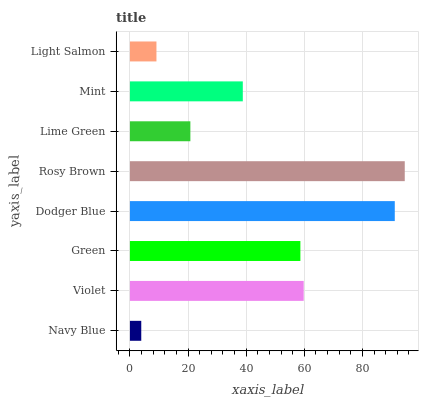Is Navy Blue the minimum?
Answer yes or no. Yes. Is Rosy Brown the maximum?
Answer yes or no. Yes. Is Violet the minimum?
Answer yes or no. No. Is Violet the maximum?
Answer yes or no. No. Is Violet greater than Navy Blue?
Answer yes or no. Yes. Is Navy Blue less than Violet?
Answer yes or no. Yes. Is Navy Blue greater than Violet?
Answer yes or no. No. Is Violet less than Navy Blue?
Answer yes or no. No. Is Green the high median?
Answer yes or no. Yes. Is Mint the low median?
Answer yes or no. Yes. Is Navy Blue the high median?
Answer yes or no. No. Is Lime Green the low median?
Answer yes or no. No. 